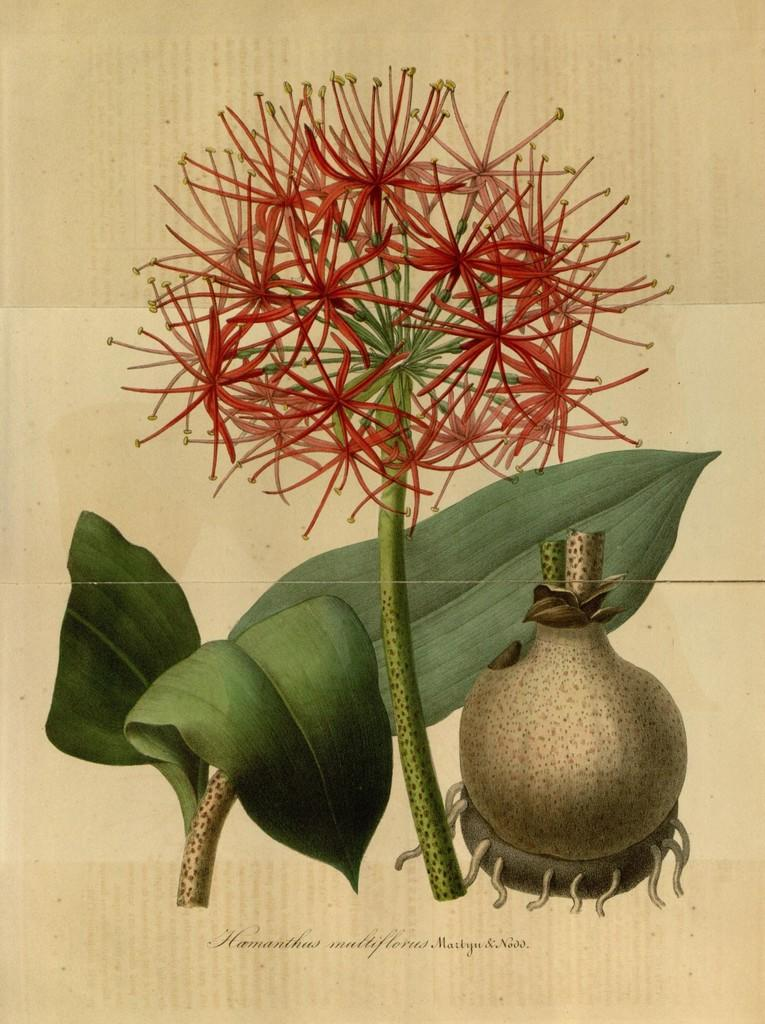What type of art is depicted in the image? The image contains an art of a flower, a plant, and a seed. What is the medium of the art in the image? The art is on a paper. How many stars can be seen in the image? There are no stars present in the image; it features art of a flower, a plant, and a seed on a paper. Can you describe the folding technique used in the art? There is no mention of folding in the image, as it is a flat art piece on paper. 